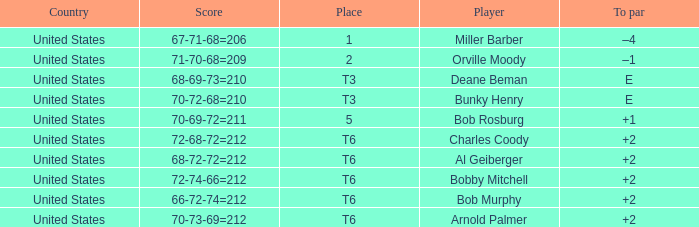Can you parse all the data within this table? {'header': ['Country', 'Score', 'Place', 'Player', 'To par'], 'rows': [['United States', '67-71-68=206', '1', 'Miller Barber', '–4'], ['United States', '71-70-68=209', '2', 'Orville Moody', '–1'], ['United States', '68-69-73=210', 'T3', 'Deane Beman', 'E'], ['United States', '70-72-68=210', 'T3', 'Bunky Henry', 'E'], ['United States', '70-69-72=211', '5', 'Bob Rosburg', '+1'], ['United States', '72-68-72=212', 'T6', 'Charles Coody', '+2'], ['United States', '68-72-72=212', 'T6', 'Al Geiberger', '+2'], ['United States', '72-74-66=212', 'T6', 'Bobby Mitchell', '+2'], ['United States', '66-72-74=212', 'T6', 'Bob Murphy', '+2'], ['United States', '70-73-69=212', 'T6', 'Arnold Palmer', '+2']]} What is the to par of player bunky henry? E. 